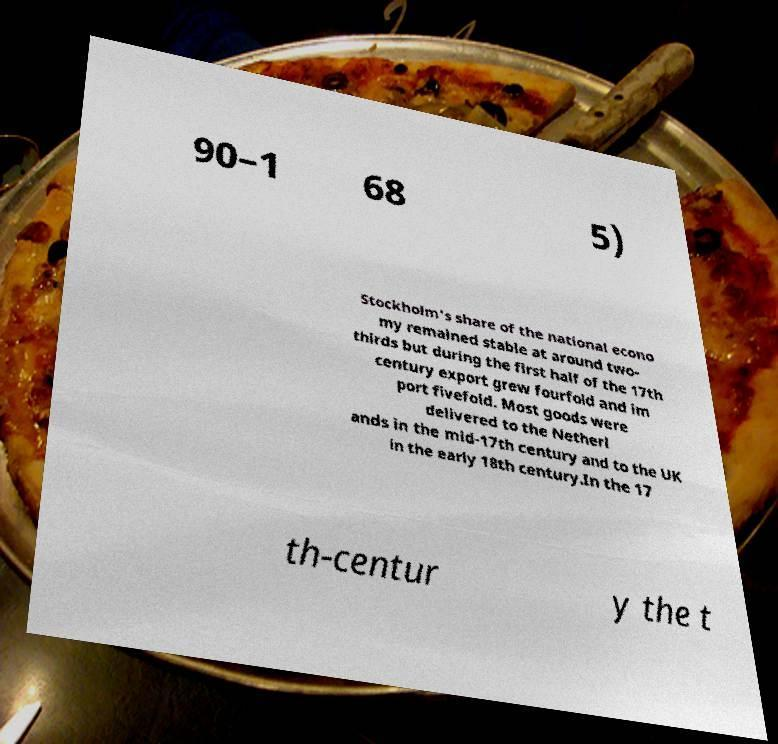There's text embedded in this image that I need extracted. Can you transcribe it verbatim? 90–1 68 5) Stockholm's share of the national econo my remained stable at around two- thirds but during the first half of the 17th century export grew fourfold and im port fivefold. Most goods were delivered to the Netherl ands in the mid-17th century and to the UK in the early 18th century.In the 17 th-centur y the t 